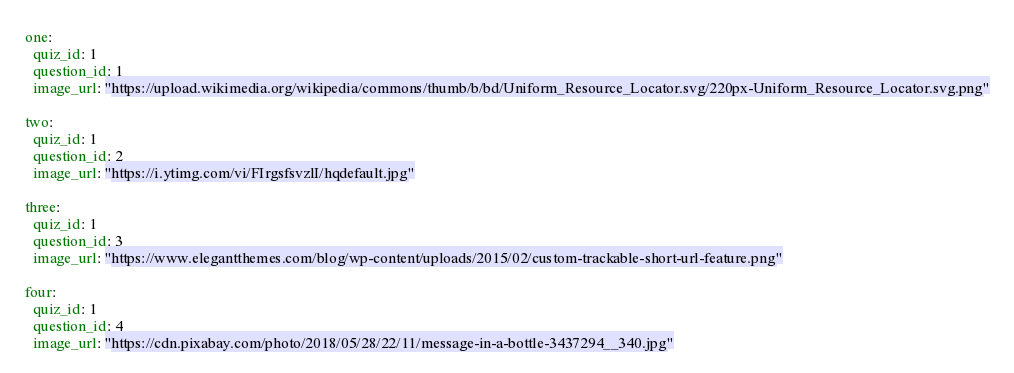Convert code to text. <code><loc_0><loc_0><loc_500><loc_500><_YAML_>one:
  quiz_id: 1
  question_id: 1
  image_url: "https://upload.wikimedia.org/wikipedia/commons/thumb/b/bd/Uniform_Resource_Locator.svg/220px-Uniform_Resource_Locator.svg.png"

two:
  quiz_id: 1
  question_id: 2
  image_url: "https://i.ytimg.com/vi/FIrgsfsvzlI/hqdefault.jpg"

three:
  quiz_id: 1
  question_id: 3
  image_url: "https://www.elegantthemes.com/blog/wp-content/uploads/2015/02/custom-trackable-short-url-feature.png"

four:
  quiz_id: 1
  question_id: 4
  image_url: "https://cdn.pixabay.com/photo/2018/05/28/22/11/message-in-a-bottle-3437294__340.jpg"</code> 